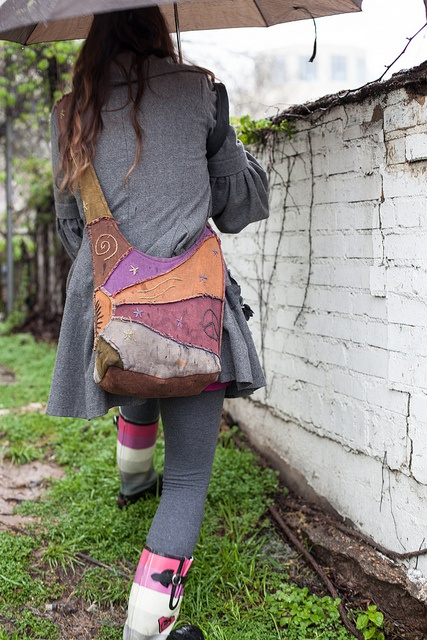Describe the objects in this image and their specific colors. I can see people in lightgray, gray, black, and darkgray tones, handbag in lightgray, brown, darkgray, violet, and salmon tones, and umbrella in lightgray, gray, and black tones in this image. 